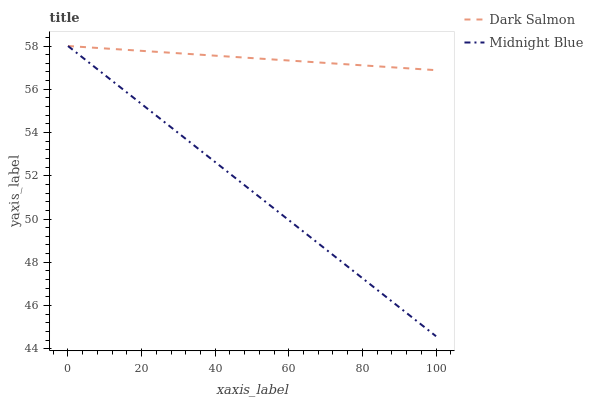Does Midnight Blue have the maximum area under the curve?
Answer yes or no. No. Is Midnight Blue the roughest?
Answer yes or no. No. 